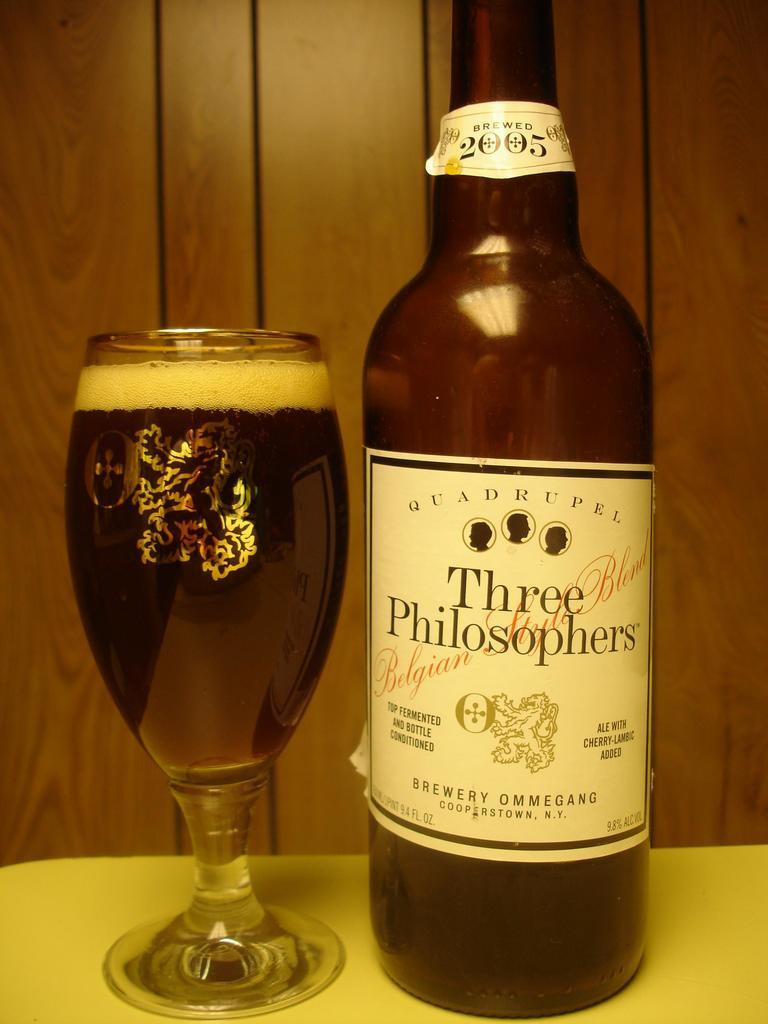Provide a one-sentence caption for the provided image. bottle of three philosophers ale next to a full glass with wood paneling behind it. 